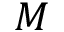<formula> <loc_0><loc_0><loc_500><loc_500>M</formula> 